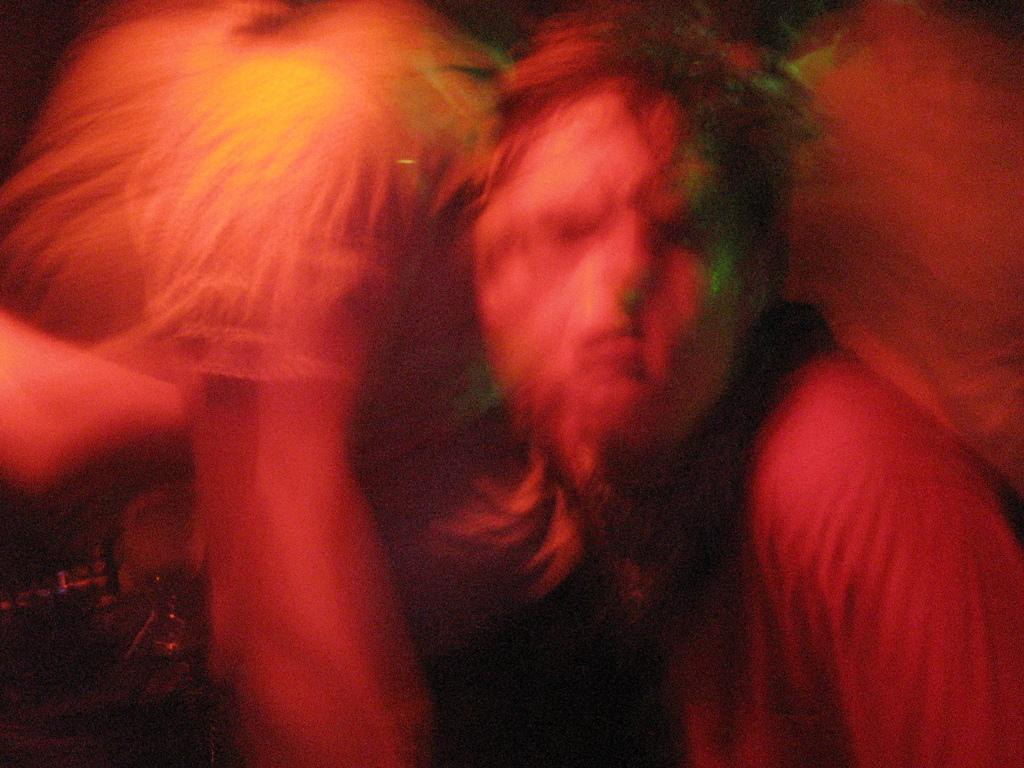Please provide a concise description of this image. This picture is blurry. In this image there is a person holding the other person. 